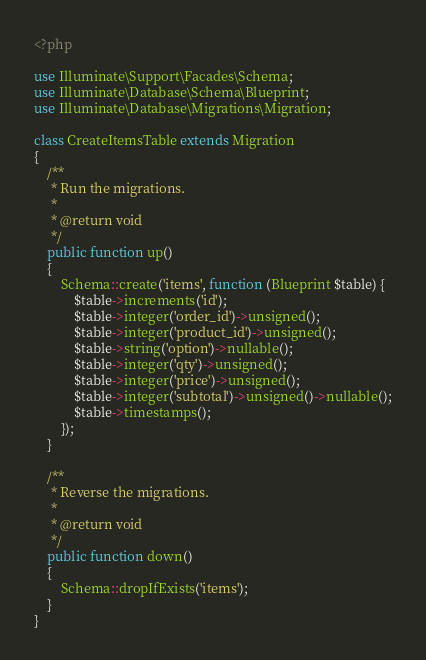<code> <loc_0><loc_0><loc_500><loc_500><_PHP_><?php

use Illuminate\Support\Facades\Schema;
use Illuminate\Database\Schema\Blueprint;
use Illuminate\Database\Migrations\Migration;

class CreateItemsTable extends Migration
{
    /**
     * Run the migrations.
     *
     * @return void
     */
    public function up()
    {
        Schema::create('items', function (Blueprint $table) {
            $table->increments('id');
            $table->integer('order_id')->unsigned();
            $table->integer('product_id')->unsigned();
            $table->string('option')->nullable();
            $table->integer('qty')->unsigned();
            $table->integer('price')->unsigned();
            $table->integer('subtotal')->unsigned()->nullable();
            $table->timestamps();
        });
    }

    /**
     * Reverse the migrations.
     *
     * @return void
     */
    public function down()
    {
        Schema::dropIfExists('items');
    }
}
</code> 